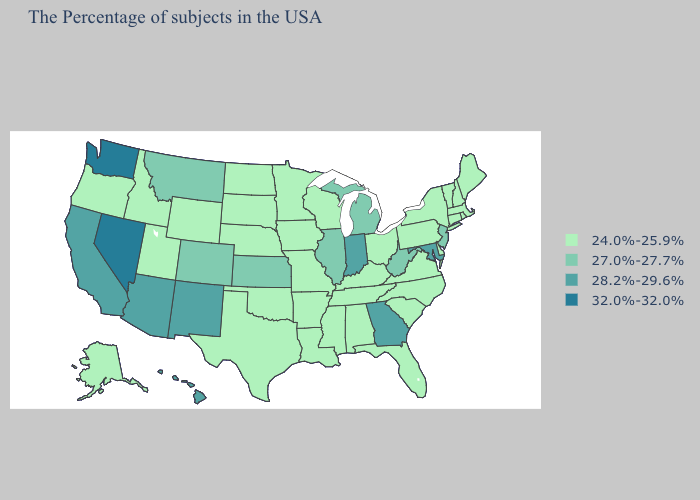Is the legend a continuous bar?
Write a very short answer. No. Name the states that have a value in the range 32.0%-32.0%?
Keep it brief. Nevada, Washington. How many symbols are there in the legend?
Keep it brief. 4. Does Utah have the highest value in the USA?
Short answer required. No. Name the states that have a value in the range 28.2%-29.6%?
Short answer required. Maryland, Georgia, Indiana, New Mexico, Arizona, California, Hawaii. Name the states that have a value in the range 24.0%-25.9%?
Quick response, please. Maine, Massachusetts, Rhode Island, New Hampshire, Vermont, Connecticut, New York, Delaware, Pennsylvania, Virginia, North Carolina, South Carolina, Ohio, Florida, Kentucky, Alabama, Tennessee, Wisconsin, Mississippi, Louisiana, Missouri, Arkansas, Minnesota, Iowa, Nebraska, Oklahoma, Texas, South Dakota, North Dakota, Wyoming, Utah, Idaho, Oregon, Alaska. Name the states that have a value in the range 32.0%-32.0%?
Quick response, please. Nevada, Washington. Does Washington have the highest value in the West?
Quick response, please. Yes. Name the states that have a value in the range 24.0%-25.9%?
Short answer required. Maine, Massachusetts, Rhode Island, New Hampshire, Vermont, Connecticut, New York, Delaware, Pennsylvania, Virginia, North Carolina, South Carolina, Ohio, Florida, Kentucky, Alabama, Tennessee, Wisconsin, Mississippi, Louisiana, Missouri, Arkansas, Minnesota, Iowa, Nebraska, Oklahoma, Texas, South Dakota, North Dakota, Wyoming, Utah, Idaho, Oregon, Alaska. What is the highest value in the West ?
Quick response, please. 32.0%-32.0%. Which states hav the highest value in the West?
Give a very brief answer. Nevada, Washington. What is the highest value in the Northeast ?
Concise answer only. 27.0%-27.7%. Does California have the lowest value in the West?
Concise answer only. No. Which states have the highest value in the USA?
Be succinct. Nevada, Washington. Name the states that have a value in the range 28.2%-29.6%?
Keep it brief. Maryland, Georgia, Indiana, New Mexico, Arizona, California, Hawaii. 